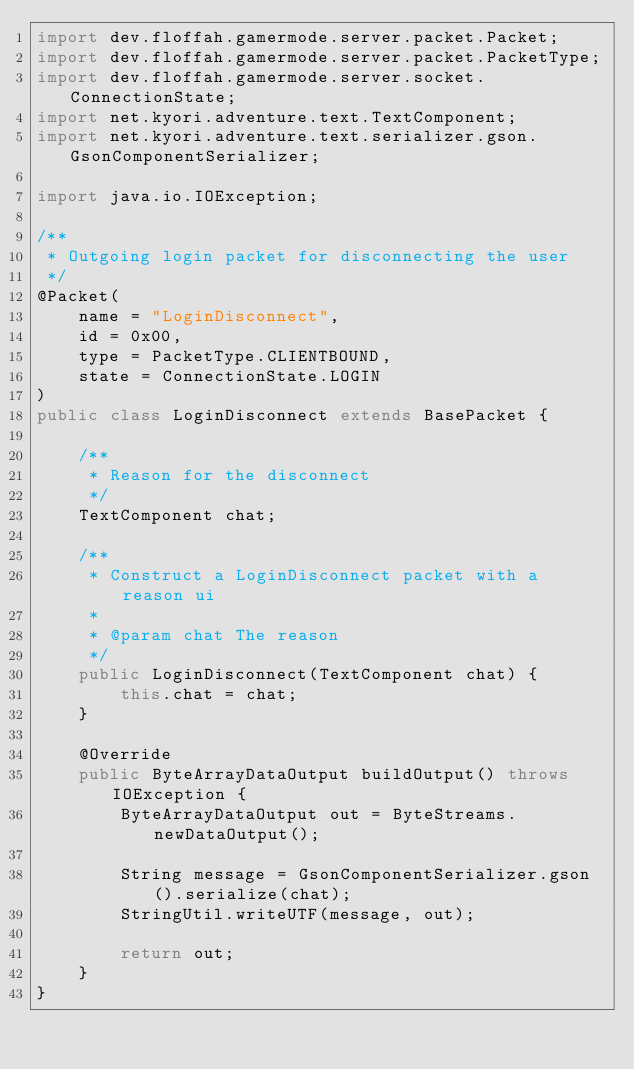Convert code to text. <code><loc_0><loc_0><loc_500><loc_500><_Java_>import dev.floffah.gamermode.server.packet.Packet;
import dev.floffah.gamermode.server.packet.PacketType;
import dev.floffah.gamermode.server.socket.ConnectionState;
import net.kyori.adventure.text.TextComponent;
import net.kyori.adventure.text.serializer.gson.GsonComponentSerializer;

import java.io.IOException;

/**
 * Outgoing login packet for disconnecting the user
 */
@Packet(
    name = "LoginDisconnect",
    id = 0x00,
    type = PacketType.CLIENTBOUND,
    state = ConnectionState.LOGIN
)
public class LoginDisconnect extends BasePacket {

    /**
     * Reason for the disconnect
     */
    TextComponent chat;

    /**
     * Construct a LoginDisconnect packet with a reason ui
     *
     * @param chat The reason
     */
    public LoginDisconnect(TextComponent chat) {
        this.chat = chat;
    }

    @Override
    public ByteArrayDataOutput buildOutput() throws IOException {
        ByteArrayDataOutput out = ByteStreams.newDataOutput();

        String message = GsonComponentSerializer.gson().serialize(chat);
        StringUtil.writeUTF(message, out);

        return out;
    }
}
</code> 